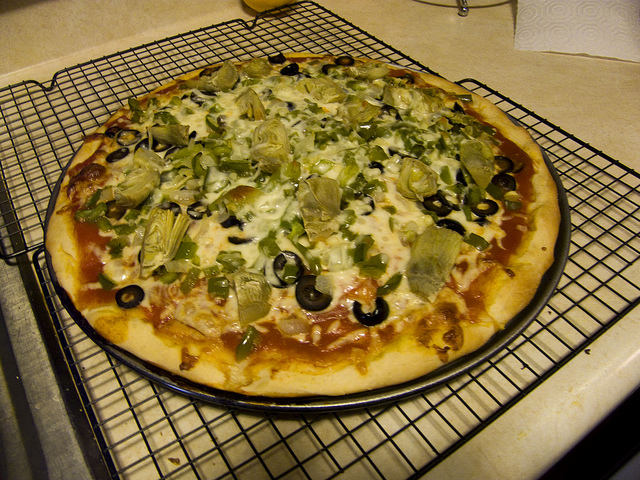<image>What fruit is on the top pizza? I am not sure what fruit is on the top pizza. It could be pineapple, olives, or even avocado. What fruit is on the top pizza? I don't know what fruit is on the top pizza. It can be seen 'artichoke', 'pineapple', 'olives', 'avocado' or none. 